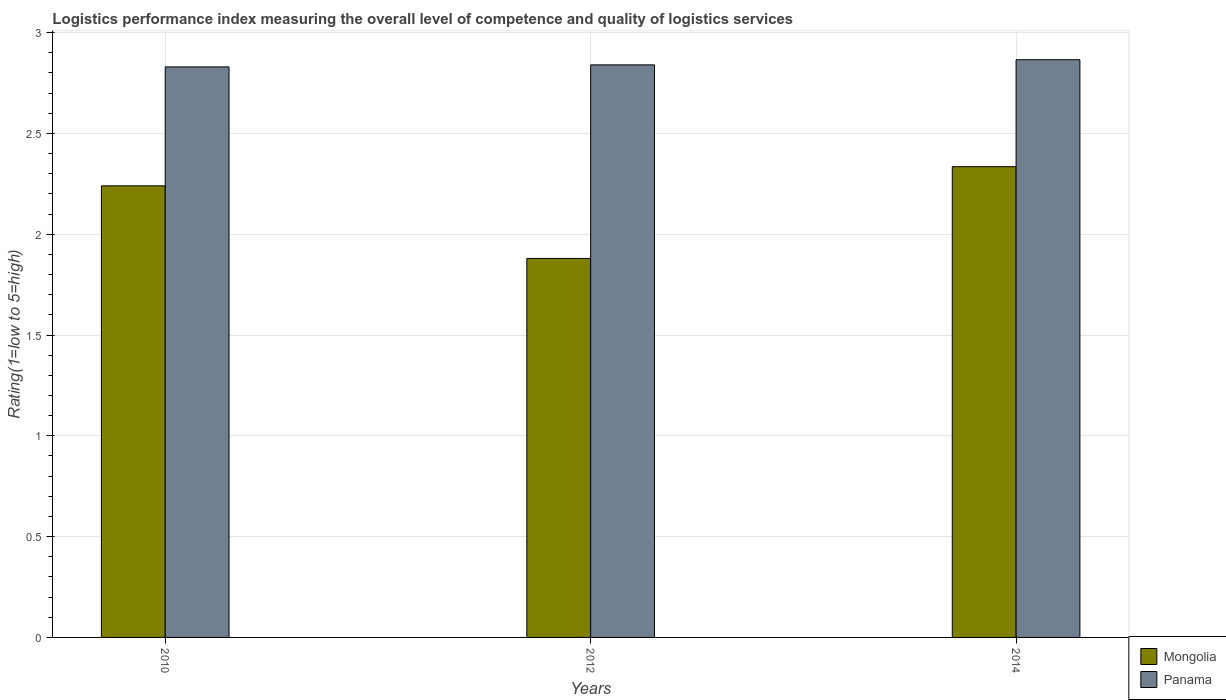How many different coloured bars are there?
Your answer should be very brief. 2. How many groups of bars are there?
Keep it short and to the point. 3. Are the number of bars on each tick of the X-axis equal?
Your response must be concise. Yes. What is the Logistic performance index in Mongolia in 2014?
Offer a terse response. 2.33. Across all years, what is the maximum Logistic performance index in Panama?
Your answer should be very brief. 2.87. Across all years, what is the minimum Logistic performance index in Panama?
Make the answer very short. 2.83. What is the total Logistic performance index in Panama in the graph?
Provide a short and direct response. 8.54. What is the difference between the Logistic performance index in Panama in 2010 and that in 2014?
Make the answer very short. -0.04. What is the difference between the Logistic performance index in Mongolia in 2010 and the Logistic performance index in Panama in 2014?
Offer a terse response. -0.63. What is the average Logistic performance index in Mongolia per year?
Offer a terse response. 2.15. In the year 2014, what is the difference between the Logistic performance index in Mongolia and Logistic performance index in Panama?
Offer a terse response. -0.53. What is the ratio of the Logistic performance index in Mongolia in 2012 to that in 2014?
Give a very brief answer. 0.81. Is the Logistic performance index in Panama in 2010 less than that in 2012?
Keep it short and to the point. Yes. What is the difference between the highest and the second highest Logistic performance index in Panama?
Your answer should be very brief. 0.03. What is the difference between the highest and the lowest Logistic performance index in Mongolia?
Offer a terse response. 0.45. In how many years, is the Logistic performance index in Mongolia greater than the average Logistic performance index in Mongolia taken over all years?
Offer a very short reply. 2. Is the sum of the Logistic performance index in Panama in 2012 and 2014 greater than the maximum Logistic performance index in Mongolia across all years?
Provide a succinct answer. Yes. What does the 2nd bar from the left in 2014 represents?
Your answer should be compact. Panama. What does the 2nd bar from the right in 2010 represents?
Make the answer very short. Mongolia. Are the values on the major ticks of Y-axis written in scientific E-notation?
Your answer should be very brief. No. Does the graph contain any zero values?
Ensure brevity in your answer.  No. Does the graph contain grids?
Keep it short and to the point. Yes. Where does the legend appear in the graph?
Provide a short and direct response. Bottom right. What is the title of the graph?
Your answer should be compact. Logistics performance index measuring the overall level of competence and quality of logistics services. What is the label or title of the X-axis?
Give a very brief answer. Years. What is the label or title of the Y-axis?
Provide a short and direct response. Rating(1=low to 5=high). What is the Rating(1=low to 5=high) of Mongolia in 2010?
Offer a terse response. 2.24. What is the Rating(1=low to 5=high) in Panama in 2010?
Ensure brevity in your answer.  2.83. What is the Rating(1=low to 5=high) in Mongolia in 2012?
Keep it short and to the point. 1.88. What is the Rating(1=low to 5=high) of Panama in 2012?
Your response must be concise. 2.84. What is the Rating(1=low to 5=high) of Mongolia in 2014?
Your answer should be very brief. 2.33. What is the Rating(1=low to 5=high) of Panama in 2014?
Provide a succinct answer. 2.87. Across all years, what is the maximum Rating(1=low to 5=high) of Mongolia?
Offer a terse response. 2.33. Across all years, what is the maximum Rating(1=low to 5=high) in Panama?
Offer a very short reply. 2.87. Across all years, what is the minimum Rating(1=low to 5=high) of Mongolia?
Ensure brevity in your answer.  1.88. Across all years, what is the minimum Rating(1=low to 5=high) in Panama?
Ensure brevity in your answer.  2.83. What is the total Rating(1=low to 5=high) of Mongolia in the graph?
Your answer should be very brief. 6.46. What is the total Rating(1=low to 5=high) of Panama in the graph?
Your answer should be very brief. 8.54. What is the difference between the Rating(1=low to 5=high) in Mongolia in 2010 and that in 2012?
Provide a short and direct response. 0.36. What is the difference between the Rating(1=low to 5=high) in Panama in 2010 and that in 2012?
Give a very brief answer. -0.01. What is the difference between the Rating(1=low to 5=high) of Mongolia in 2010 and that in 2014?
Offer a very short reply. -0.1. What is the difference between the Rating(1=low to 5=high) in Panama in 2010 and that in 2014?
Provide a short and direct response. -0.04. What is the difference between the Rating(1=low to 5=high) of Mongolia in 2012 and that in 2014?
Give a very brief answer. -0.46. What is the difference between the Rating(1=low to 5=high) of Panama in 2012 and that in 2014?
Keep it short and to the point. -0.03. What is the difference between the Rating(1=low to 5=high) in Mongolia in 2010 and the Rating(1=low to 5=high) in Panama in 2012?
Provide a short and direct response. -0.6. What is the difference between the Rating(1=low to 5=high) of Mongolia in 2010 and the Rating(1=low to 5=high) of Panama in 2014?
Offer a very short reply. -0.63. What is the difference between the Rating(1=low to 5=high) in Mongolia in 2012 and the Rating(1=low to 5=high) in Panama in 2014?
Give a very brief answer. -0.99. What is the average Rating(1=low to 5=high) in Mongolia per year?
Keep it short and to the point. 2.15. What is the average Rating(1=low to 5=high) in Panama per year?
Ensure brevity in your answer.  2.85. In the year 2010, what is the difference between the Rating(1=low to 5=high) in Mongolia and Rating(1=low to 5=high) in Panama?
Offer a very short reply. -0.59. In the year 2012, what is the difference between the Rating(1=low to 5=high) in Mongolia and Rating(1=low to 5=high) in Panama?
Ensure brevity in your answer.  -0.96. In the year 2014, what is the difference between the Rating(1=low to 5=high) in Mongolia and Rating(1=low to 5=high) in Panama?
Your answer should be very brief. -0.53. What is the ratio of the Rating(1=low to 5=high) in Mongolia in 2010 to that in 2012?
Your answer should be very brief. 1.19. What is the ratio of the Rating(1=low to 5=high) of Panama in 2010 to that in 2012?
Give a very brief answer. 1. What is the ratio of the Rating(1=low to 5=high) of Mongolia in 2010 to that in 2014?
Make the answer very short. 0.96. What is the ratio of the Rating(1=low to 5=high) in Panama in 2010 to that in 2014?
Offer a very short reply. 0.99. What is the ratio of the Rating(1=low to 5=high) of Mongolia in 2012 to that in 2014?
Your answer should be very brief. 0.81. What is the difference between the highest and the second highest Rating(1=low to 5=high) of Mongolia?
Make the answer very short. 0.1. What is the difference between the highest and the second highest Rating(1=low to 5=high) in Panama?
Make the answer very short. 0.03. What is the difference between the highest and the lowest Rating(1=low to 5=high) of Mongolia?
Offer a terse response. 0.46. What is the difference between the highest and the lowest Rating(1=low to 5=high) in Panama?
Give a very brief answer. 0.04. 